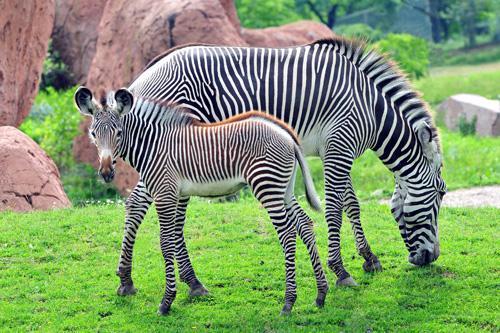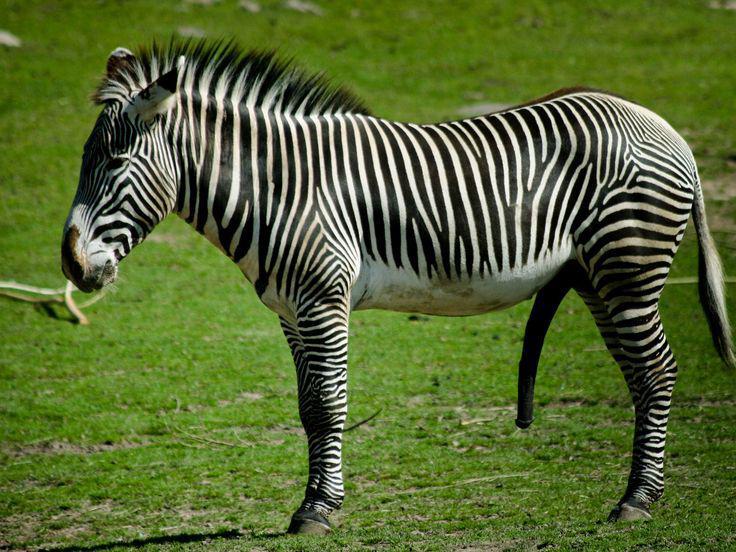The first image is the image on the left, the second image is the image on the right. Considering the images on both sides, is "The left image shows exactly two zebras while the right image shows exactly one." valid? Answer yes or no. Yes. The first image is the image on the left, the second image is the image on the right. Given the left and right images, does the statement "The images contain a total of three zebras." hold true? Answer yes or no. Yes. 